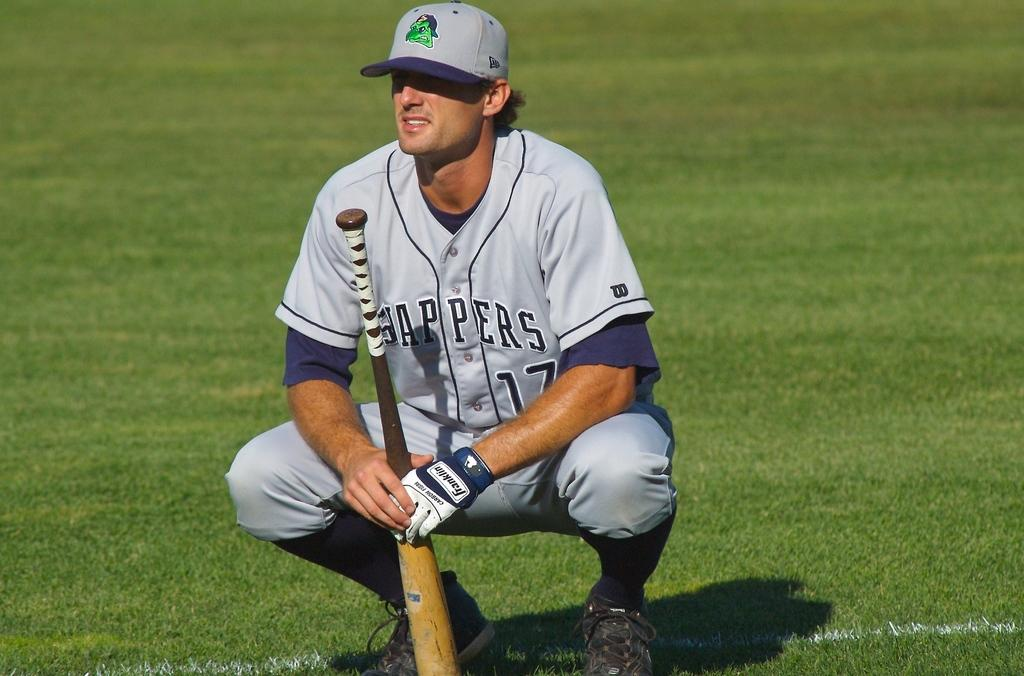Who is present in the image? There is a person in the image. What is the person wearing on their head? The person is wearing a cap. What is the person wearing on their hands? The person is wearing gloves. What position is the person in? The person is in a squat position. What object is the person holding? The person is holding a bat. What type of surface is visible on the ground in the image? There is grass on the ground in the image. What type of smoke can be seen coming from the bat in the image? There is no smoke coming from the bat in the image. The bat is an object used for hitting balls, not producing smoke. 